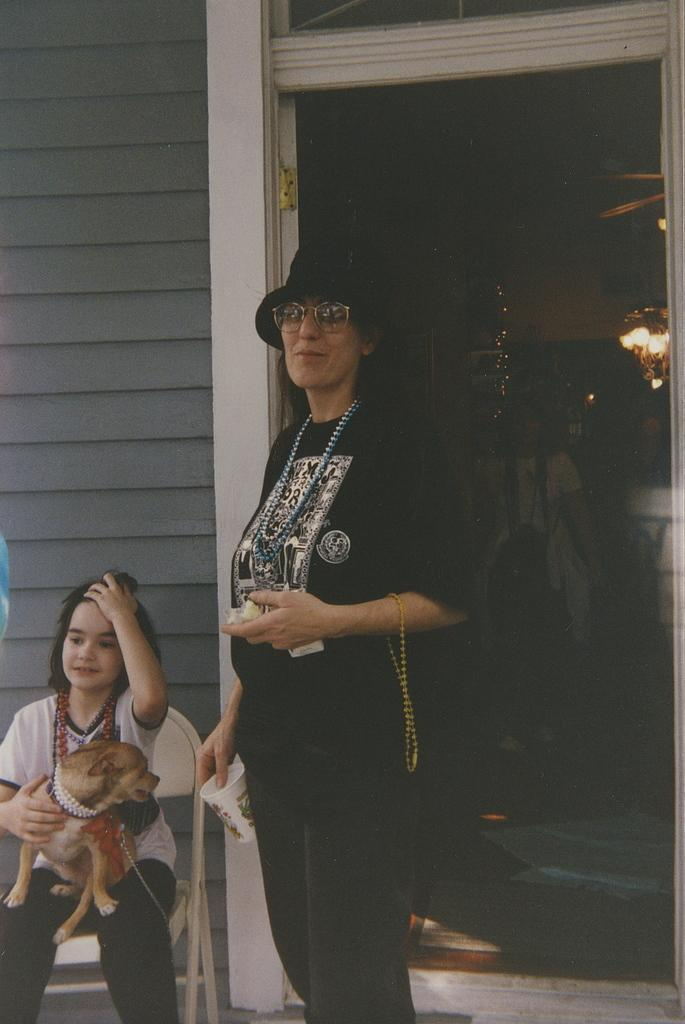What is the primary subject of the image? There is a woman standing in the image. Can you describe the position of the girl in the image? There is a girl seated in the image. What is the girl doing with her hand? The girl is holding a dog with her hand. What type of structure is visible in the image? There is a house visible in the image. What type of meal is being prepared in the image? There is no indication of a meal being prepared in the image. Can you describe the waves in the image? There are no waves present in the image. 